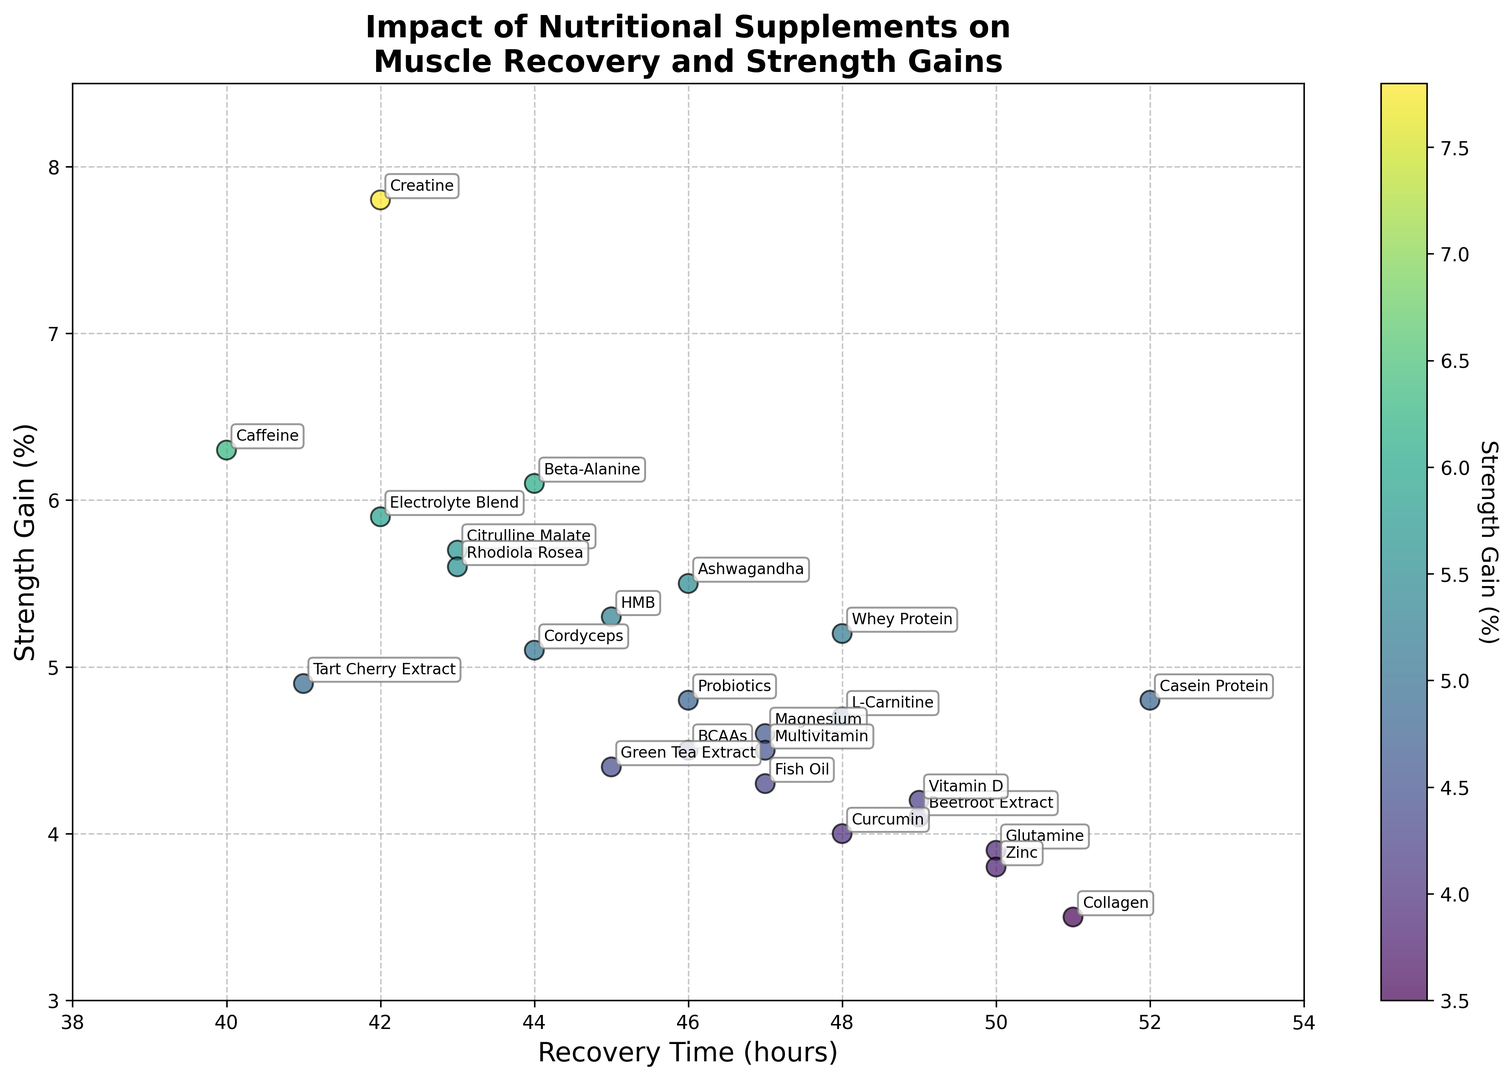Which supplement has the shortest recovery time? The shortest recovery time is indicated by the leftmost point on the x-axis of the plot. The supplement with the shortest recovery time of 40 hours is Caffeine.
Answer: Caffeine Which supplement shows the highest strength gain? The highest strength gain is shown by the tallest point on the y-axis of the plot. The supplement with the highest strength gain of 7.8% is Creatine.
Answer: Creatine Which supplement has the longest recovery time but offers less than 5% strength gain? The supplement with the longest recovery time is at the rightmost point on the x-axis. Checking supplements with recovery time and strength gain criteria, the supplement with a recovery time of 52 hours and less than 5% strength gain is Casein Protein.
Answer: Casein Protein Compare the recovery times of whey protein and casein protein. Whey Protein has a recovery time of 48 hours, whereas Casein Protein has a recovery time of 52 hours. So, Casein Protein takes longer for recovery than Whey Protein.
Answer: Casein Protein takes longer Which supplements have a strength gain between 5% and 6%? To identify supplements with strength gains in the specified range, we look at the points vertically located between 5% to 6% on the y-axis. These supplements are Whey Protein (5.2%), Citrulline Malate (5.7%), HMB (5.3%), Ashwagandha (5.5%), and Rhodiola Rosea (5.6%).
Answer: Whey Protein, Citrulline Malate, HMB, Ashwagandha, Rhodiola Rosea What's the average recovery time of supplements that have strength gains above 5%? First, identify the supplements with strength gains above 5%: Whey Protein, Creatine, Beta-Alanine, Citrulline Malate, HMB, Caffeine, Electrolyte Blend, Ashwagandha, and Rhodiola Rosea. Then calculate the average of their recovery times: (48+42+44+43+45+40+42+46+43) / 9 = 393 / 9 ≈ 43.7 hours.
Answer: 43.7 hours Identify the supplement with the highest strength gain in the range of 44 to 50 hours of recovery time. First, identify supplements within the 44 to 50 hours recovery time frame and then find the highest strength gain among them. Creatine (42, 7.8%), BCAAs (46, 4.5%), Beta-Alanine (44, 6.1%), Fish Oil (47, 4.3%), Citrulline Malate (43, 5.7%), HMB (45, 5.3%), Ashwagandha (46, 5.5%), and Cordyceps (44, 5.1%). The highest is Creatine with 42 hours and 7.8% strength gain.
Answer: Creatine What supplements have a recovery time of 48 hours, and how do their strength gains compare? Identify points at 48 hours on the x-axis and compare their strength gains. The supplements are Whey Protein (5.2%), L-Carnitine (4.7%), and Curcumin (4.0%). Whey Protein has the highest strength gain among them.
Answer: Whey Protein, L-Carnitine, and Curcumin; Whey Protein has the highest gain 